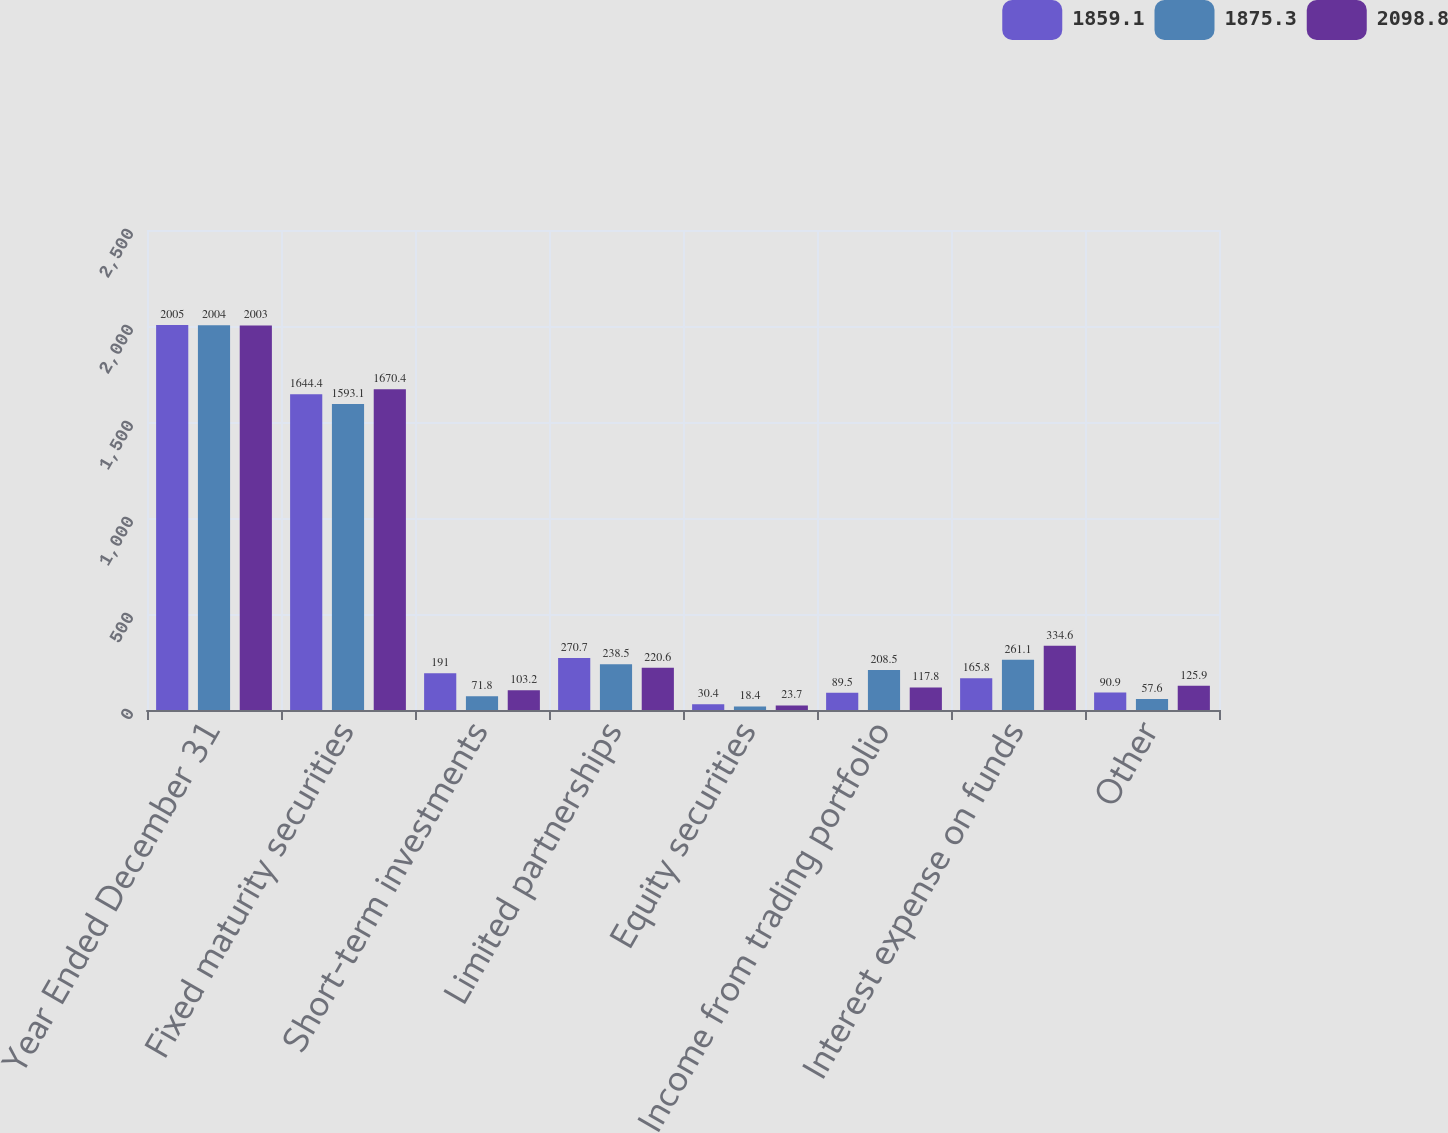Convert chart. <chart><loc_0><loc_0><loc_500><loc_500><stacked_bar_chart><ecel><fcel>Year Ended December 31<fcel>Fixed maturity securities<fcel>Short-term investments<fcel>Limited partnerships<fcel>Equity securities<fcel>Income from trading portfolio<fcel>Interest expense on funds<fcel>Other<nl><fcel>1859.1<fcel>2005<fcel>1644.4<fcel>191<fcel>270.7<fcel>30.4<fcel>89.5<fcel>165.8<fcel>90.9<nl><fcel>1875.3<fcel>2004<fcel>1593.1<fcel>71.8<fcel>238.5<fcel>18.4<fcel>208.5<fcel>261.1<fcel>57.6<nl><fcel>2098.8<fcel>2003<fcel>1670.4<fcel>103.2<fcel>220.6<fcel>23.7<fcel>117.8<fcel>334.6<fcel>125.9<nl></chart> 